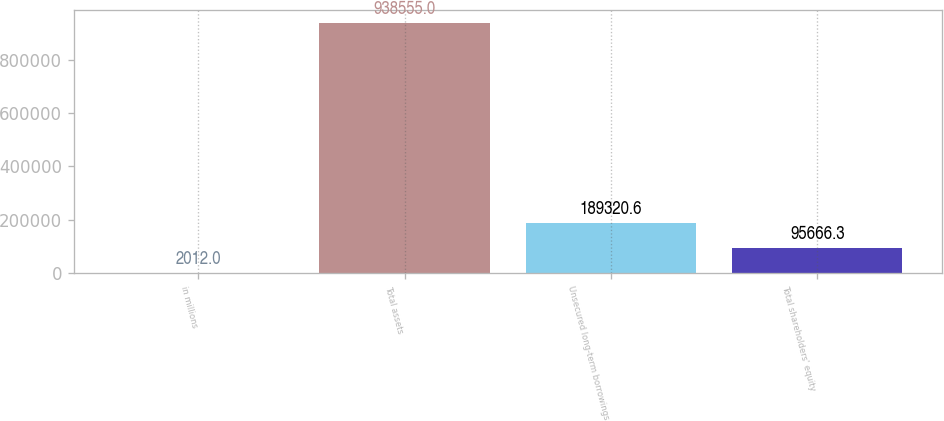Convert chart to OTSL. <chart><loc_0><loc_0><loc_500><loc_500><bar_chart><fcel>in millions<fcel>Total assets<fcel>Unsecured long-term borrowings<fcel>Total shareholders' equity<nl><fcel>2012<fcel>938555<fcel>189321<fcel>95666.3<nl></chart> 